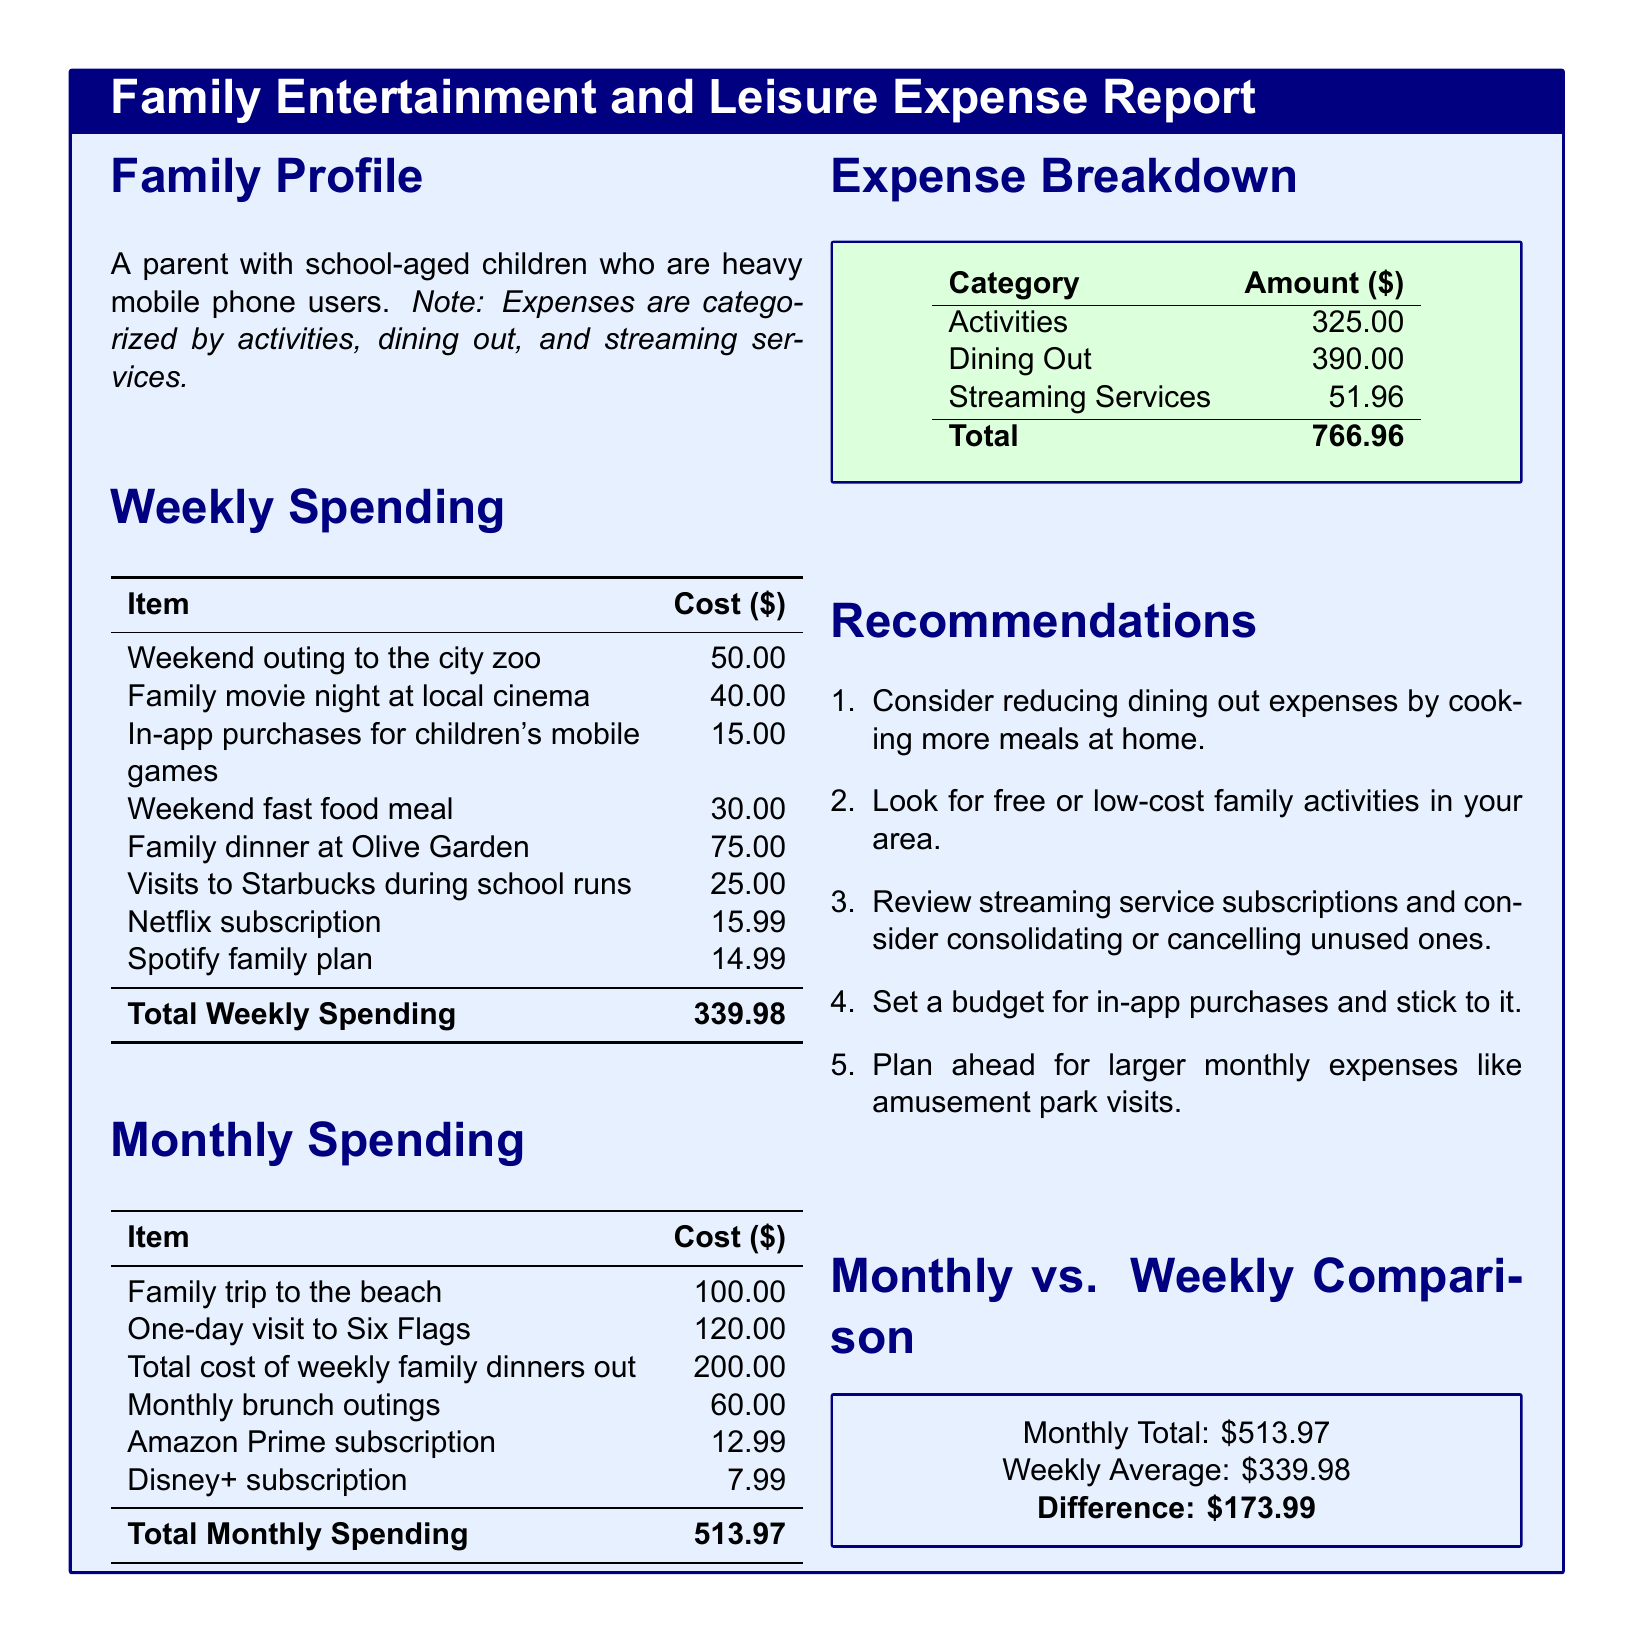what is the total weekly spending? The total weekly spending is calculated by summing all the weekly expenses listed in the document.
Answer: 339.98 what is the cost of a family trip to the beach? The cost for the family trip to the beach is specifically listed in the monthly spending section of the document.
Answer: 100.00 how much was spent on in-app purchases for children's mobile games? The in-app purchases cost is provided in the weekly spending table of the document.
Answer: 15.00 what is the total spending on streaming services? The total spending on streaming services is the sum of Netflix, Spotify, Amazon Prime, and Disney+ subscriptions.
Answer: 51.96 what is the recommendation for dining out expenses? The document provides a recommendation regarding dining out expenses that suggests a specific action to reduce costs.
Answer: cooking more meals at home how much does the family spend on dining out weekly? The weekly dining out expenses are detailed in the weekly spending section, showing the total cost associated with dining out each week.
Answer: 75.00 which activity had the highest cost in the monthly spending? By assessing the monthly spending items, you can identify which specific activity incurred the most expense.
Answer: One-day visit to Six Flags what is the difference between the monthly and weekly average spending? The document calculates the difference between the total monthly spending and the total weekly spending, providing a clear numerical difference.
Answer: 173.99 how much money was spent on activities this month? The monthly expense breakdown shows the total spending allocated to activities.
Answer: 325.00 